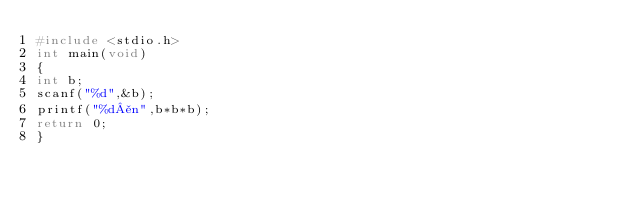Convert code to text. <code><loc_0><loc_0><loc_500><loc_500><_C_>#include <stdio.h>
int main(void)
{
int b;
scanf("%d",&b);
printf("%d¥n",b*b*b);
return 0;
}

</code> 